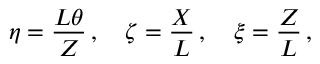<formula> <loc_0><loc_0><loc_500><loc_500>\eta = \frac { L \theta } { Z } \, , \quad z e t a = \frac { X } { L } \, , \quad x i = \frac { Z } { L } \, ,</formula> 